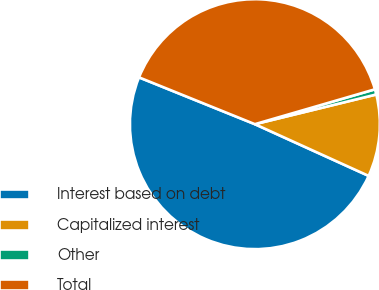<chart> <loc_0><loc_0><loc_500><loc_500><pie_chart><fcel>Interest based on debt<fcel>Capitalized interest<fcel>Other<fcel>Total<nl><fcel>49.32%<fcel>10.61%<fcel>0.68%<fcel>39.39%<nl></chart> 